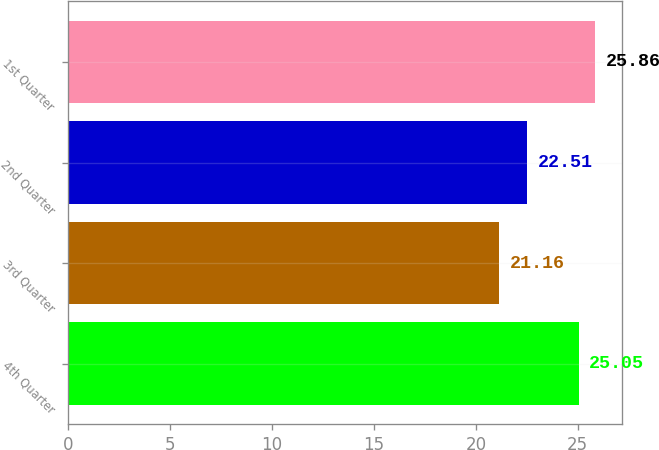Convert chart to OTSL. <chart><loc_0><loc_0><loc_500><loc_500><bar_chart><fcel>4th Quarter<fcel>3rd Quarter<fcel>2nd Quarter<fcel>1st Quarter<nl><fcel>25.05<fcel>21.16<fcel>22.51<fcel>25.86<nl></chart> 